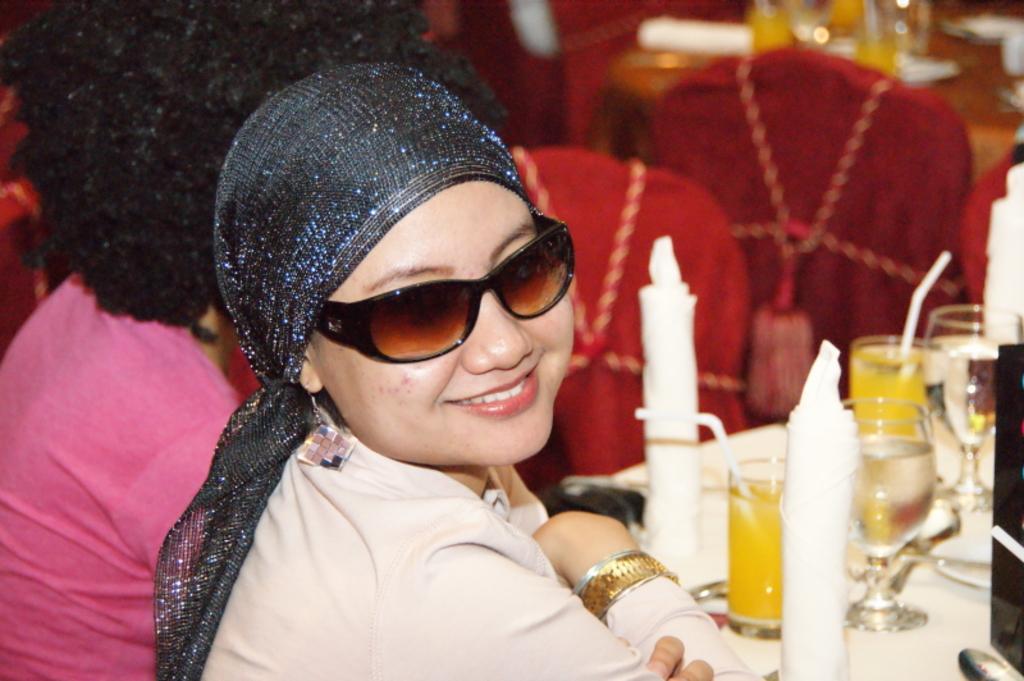In one or two sentences, can you explain what this image depicts? In this picture I can see a woman in front of the table, on which we can see few objects are placed, behind we can see few people, some chairs, tables and some objects. 